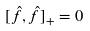<formula> <loc_0><loc_0><loc_500><loc_500>[ \hat { f } , \hat { f } ] _ { + } = 0</formula> 